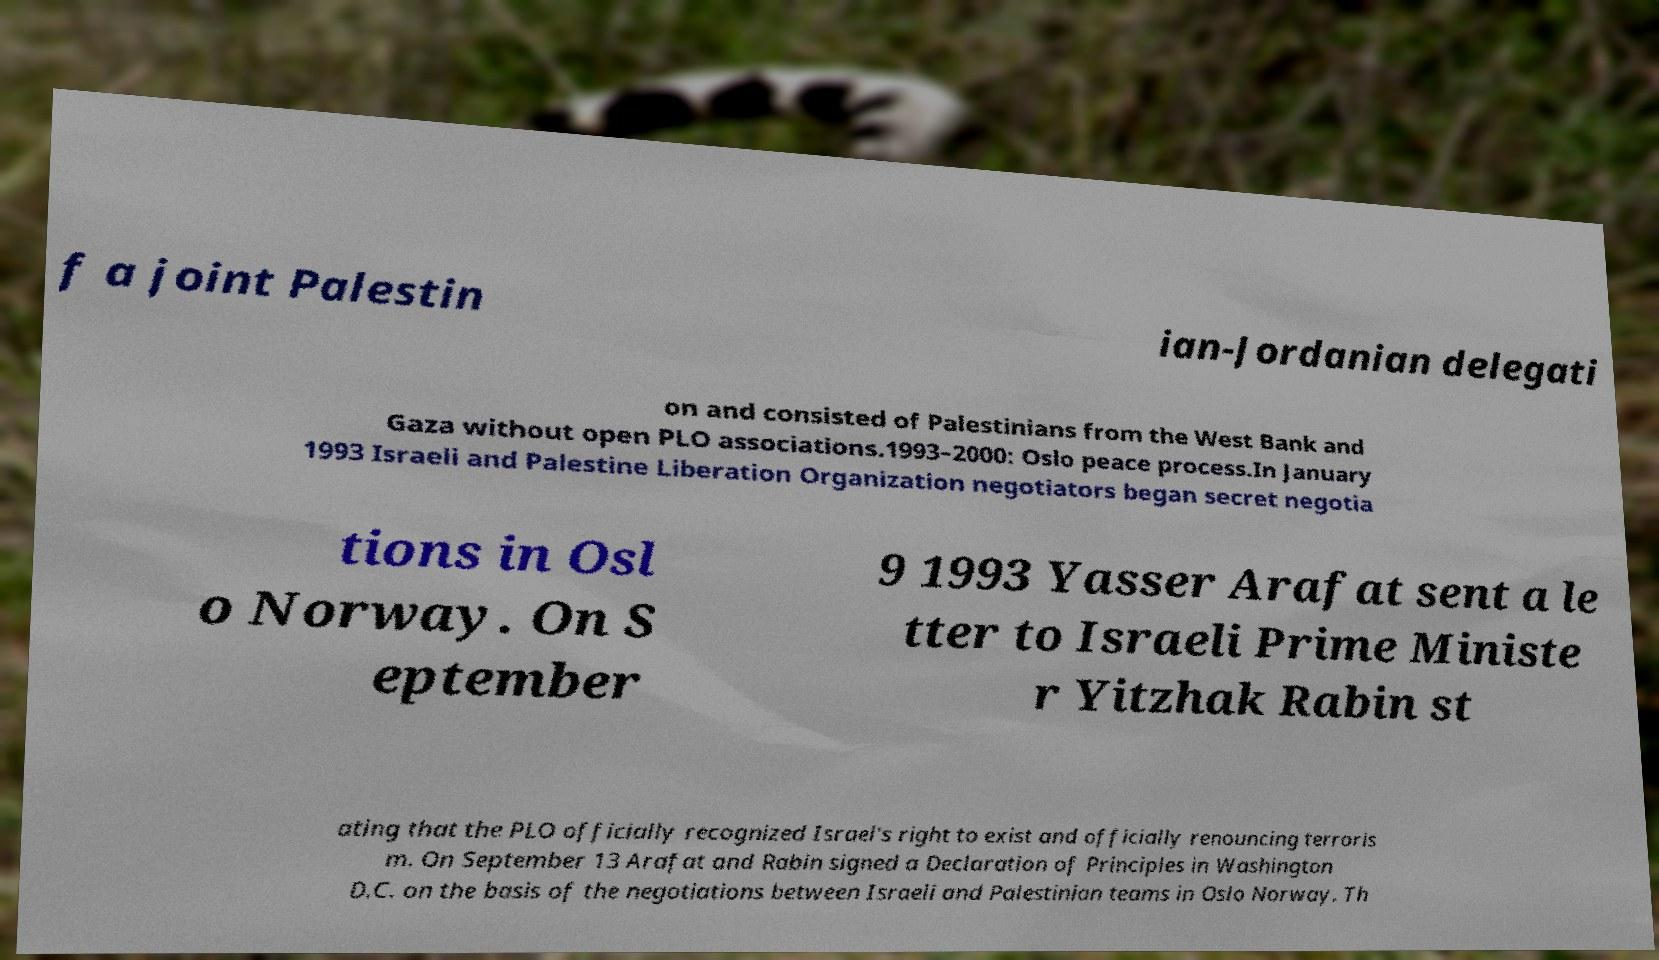What messages or text are displayed in this image? I need them in a readable, typed format. f a joint Palestin ian-Jordanian delegati on and consisted of Palestinians from the West Bank and Gaza without open PLO associations.1993–2000: Oslo peace process.In January 1993 Israeli and Palestine Liberation Organization negotiators began secret negotia tions in Osl o Norway. On S eptember 9 1993 Yasser Arafat sent a le tter to Israeli Prime Ministe r Yitzhak Rabin st ating that the PLO officially recognized Israel's right to exist and officially renouncing terroris m. On September 13 Arafat and Rabin signed a Declaration of Principles in Washington D.C. on the basis of the negotiations between Israeli and Palestinian teams in Oslo Norway. Th 